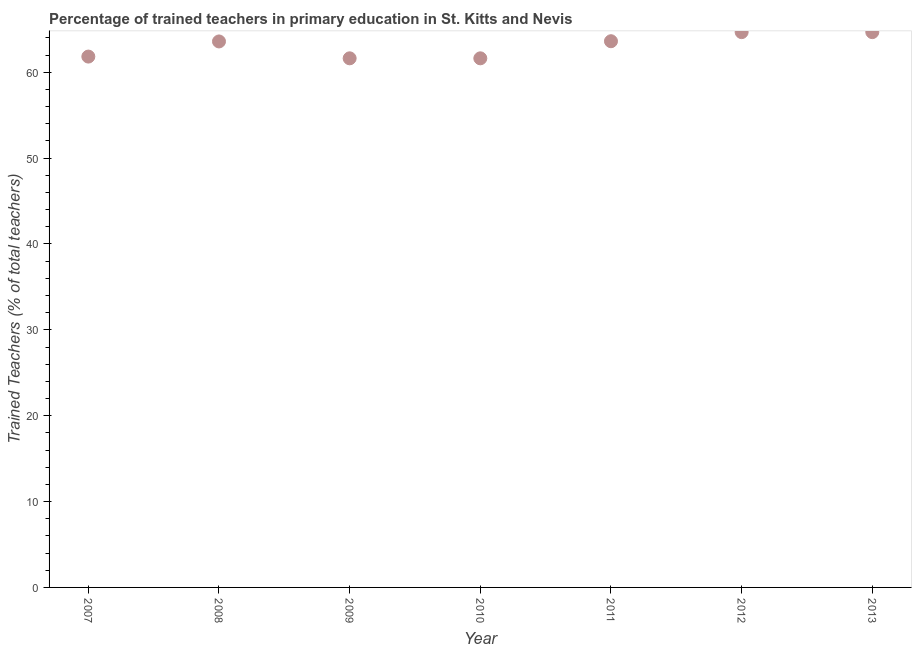What is the percentage of trained teachers in 2011?
Keep it short and to the point. 63.62. Across all years, what is the maximum percentage of trained teachers?
Offer a very short reply. 64.68. Across all years, what is the minimum percentage of trained teachers?
Your answer should be compact. 61.63. In which year was the percentage of trained teachers maximum?
Make the answer very short. 2012. What is the sum of the percentage of trained teachers?
Offer a very short reply. 441.64. What is the difference between the percentage of trained teachers in 2010 and 2011?
Offer a very short reply. -1.99. What is the average percentage of trained teachers per year?
Your answer should be very brief. 63.09. What is the median percentage of trained teachers?
Keep it short and to the point. 63.59. In how many years, is the percentage of trained teachers greater than 38 %?
Offer a very short reply. 7. Do a majority of the years between 2010 and 2011 (inclusive) have percentage of trained teachers greater than 14 %?
Offer a terse response. Yes. What is the ratio of the percentage of trained teachers in 2010 to that in 2013?
Give a very brief answer. 0.95. Is the percentage of trained teachers in 2012 less than that in 2013?
Your answer should be compact. No. What is the difference between the highest and the second highest percentage of trained teachers?
Keep it short and to the point. 0. Is the sum of the percentage of trained teachers in 2008 and 2013 greater than the maximum percentage of trained teachers across all years?
Your response must be concise. Yes. What is the difference between the highest and the lowest percentage of trained teachers?
Your response must be concise. 3.05. How many years are there in the graph?
Your response must be concise. 7. Are the values on the major ticks of Y-axis written in scientific E-notation?
Ensure brevity in your answer.  No. What is the title of the graph?
Offer a terse response. Percentage of trained teachers in primary education in St. Kitts and Nevis. What is the label or title of the X-axis?
Provide a short and direct response. Year. What is the label or title of the Y-axis?
Ensure brevity in your answer.  Trained Teachers (% of total teachers). What is the Trained Teachers (% of total teachers) in 2007?
Provide a short and direct response. 61.83. What is the Trained Teachers (% of total teachers) in 2008?
Keep it short and to the point. 63.59. What is the Trained Teachers (% of total teachers) in 2009?
Your answer should be very brief. 61.63. What is the Trained Teachers (% of total teachers) in 2010?
Your response must be concise. 61.63. What is the Trained Teachers (% of total teachers) in 2011?
Give a very brief answer. 63.62. What is the Trained Teachers (% of total teachers) in 2012?
Your response must be concise. 64.68. What is the Trained Teachers (% of total teachers) in 2013?
Your answer should be very brief. 64.68. What is the difference between the Trained Teachers (% of total teachers) in 2007 and 2008?
Your answer should be very brief. -1.76. What is the difference between the Trained Teachers (% of total teachers) in 2007 and 2009?
Provide a succinct answer. 0.2. What is the difference between the Trained Teachers (% of total teachers) in 2007 and 2010?
Your answer should be compact. 0.2. What is the difference between the Trained Teachers (% of total teachers) in 2007 and 2011?
Provide a short and direct response. -1.79. What is the difference between the Trained Teachers (% of total teachers) in 2007 and 2012?
Give a very brief answer. -2.85. What is the difference between the Trained Teachers (% of total teachers) in 2007 and 2013?
Your answer should be very brief. -2.85. What is the difference between the Trained Teachers (% of total teachers) in 2008 and 2009?
Your answer should be compact. 1.97. What is the difference between the Trained Teachers (% of total teachers) in 2008 and 2010?
Offer a terse response. 1.97. What is the difference between the Trained Teachers (% of total teachers) in 2008 and 2011?
Your answer should be compact. -0.03. What is the difference between the Trained Teachers (% of total teachers) in 2008 and 2012?
Keep it short and to the point. -1.08. What is the difference between the Trained Teachers (% of total teachers) in 2008 and 2013?
Make the answer very short. -1.08. What is the difference between the Trained Teachers (% of total teachers) in 2009 and 2010?
Offer a terse response. 0. What is the difference between the Trained Teachers (% of total teachers) in 2009 and 2011?
Make the answer very short. -1.99. What is the difference between the Trained Teachers (% of total teachers) in 2009 and 2012?
Offer a terse response. -3.05. What is the difference between the Trained Teachers (% of total teachers) in 2009 and 2013?
Ensure brevity in your answer.  -3.05. What is the difference between the Trained Teachers (% of total teachers) in 2010 and 2011?
Offer a very short reply. -1.99. What is the difference between the Trained Teachers (% of total teachers) in 2010 and 2012?
Your answer should be very brief. -3.05. What is the difference between the Trained Teachers (% of total teachers) in 2010 and 2013?
Your response must be concise. -3.05. What is the difference between the Trained Teachers (% of total teachers) in 2011 and 2012?
Offer a very short reply. -1.06. What is the difference between the Trained Teachers (% of total teachers) in 2011 and 2013?
Your answer should be very brief. -1.06. What is the ratio of the Trained Teachers (% of total teachers) in 2007 to that in 2012?
Make the answer very short. 0.96. What is the ratio of the Trained Teachers (% of total teachers) in 2007 to that in 2013?
Offer a terse response. 0.96. What is the ratio of the Trained Teachers (% of total teachers) in 2008 to that in 2009?
Provide a succinct answer. 1.03. What is the ratio of the Trained Teachers (% of total teachers) in 2008 to that in 2010?
Keep it short and to the point. 1.03. What is the ratio of the Trained Teachers (% of total teachers) in 2008 to that in 2011?
Offer a very short reply. 1. What is the ratio of the Trained Teachers (% of total teachers) in 2009 to that in 2010?
Your answer should be compact. 1. What is the ratio of the Trained Teachers (% of total teachers) in 2009 to that in 2012?
Your response must be concise. 0.95. What is the ratio of the Trained Teachers (% of total teachers) in 2009 to that in 2013?
Provide a succinct answer. 0.95. What is the ratio of the Trained Teachers (% of total teachers) in 2010 to that in 2012?
Give a very brief answer. 0.95. What is the ratio of the Trained Teachers (% of total teachers) in 2010 to that in 2013?
Offer a very short reply. 0.95. 